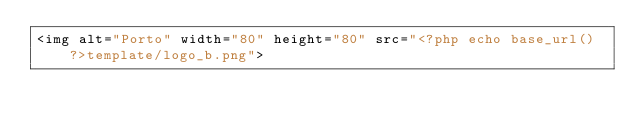<code> <loc_0><loc_0><loc_500><loc_500><_PHP_><img alt="Porto" width="80" height="80" src="<?php echo base_url()?>template/logo_b.png"></code> 